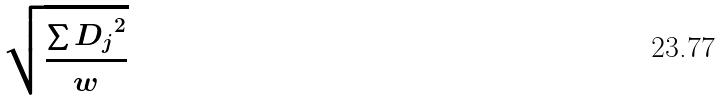<formula> <loc_0><loc_0><loc_500><loc_500>\sqrt { \frac { \sum { D _ { j } } ^ { 2 } } { w } }</formula> 